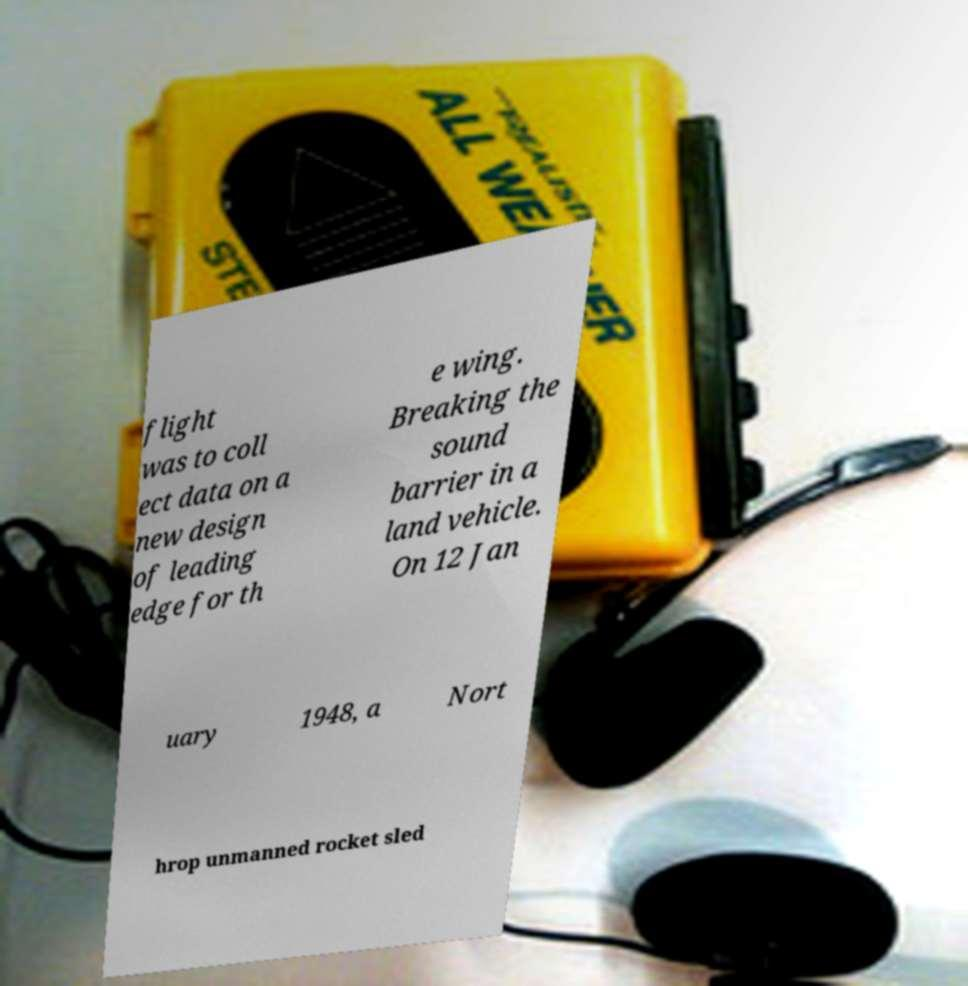What messages or text are displayed in this image? I need them in a readable, typed format. flight was to coll ect data on a new design of leading edge for th e wing. Breaking the sound barrier in a land vehicle. On 12 Jan uary 1948, a Nort hrop unmanned rocket sled 